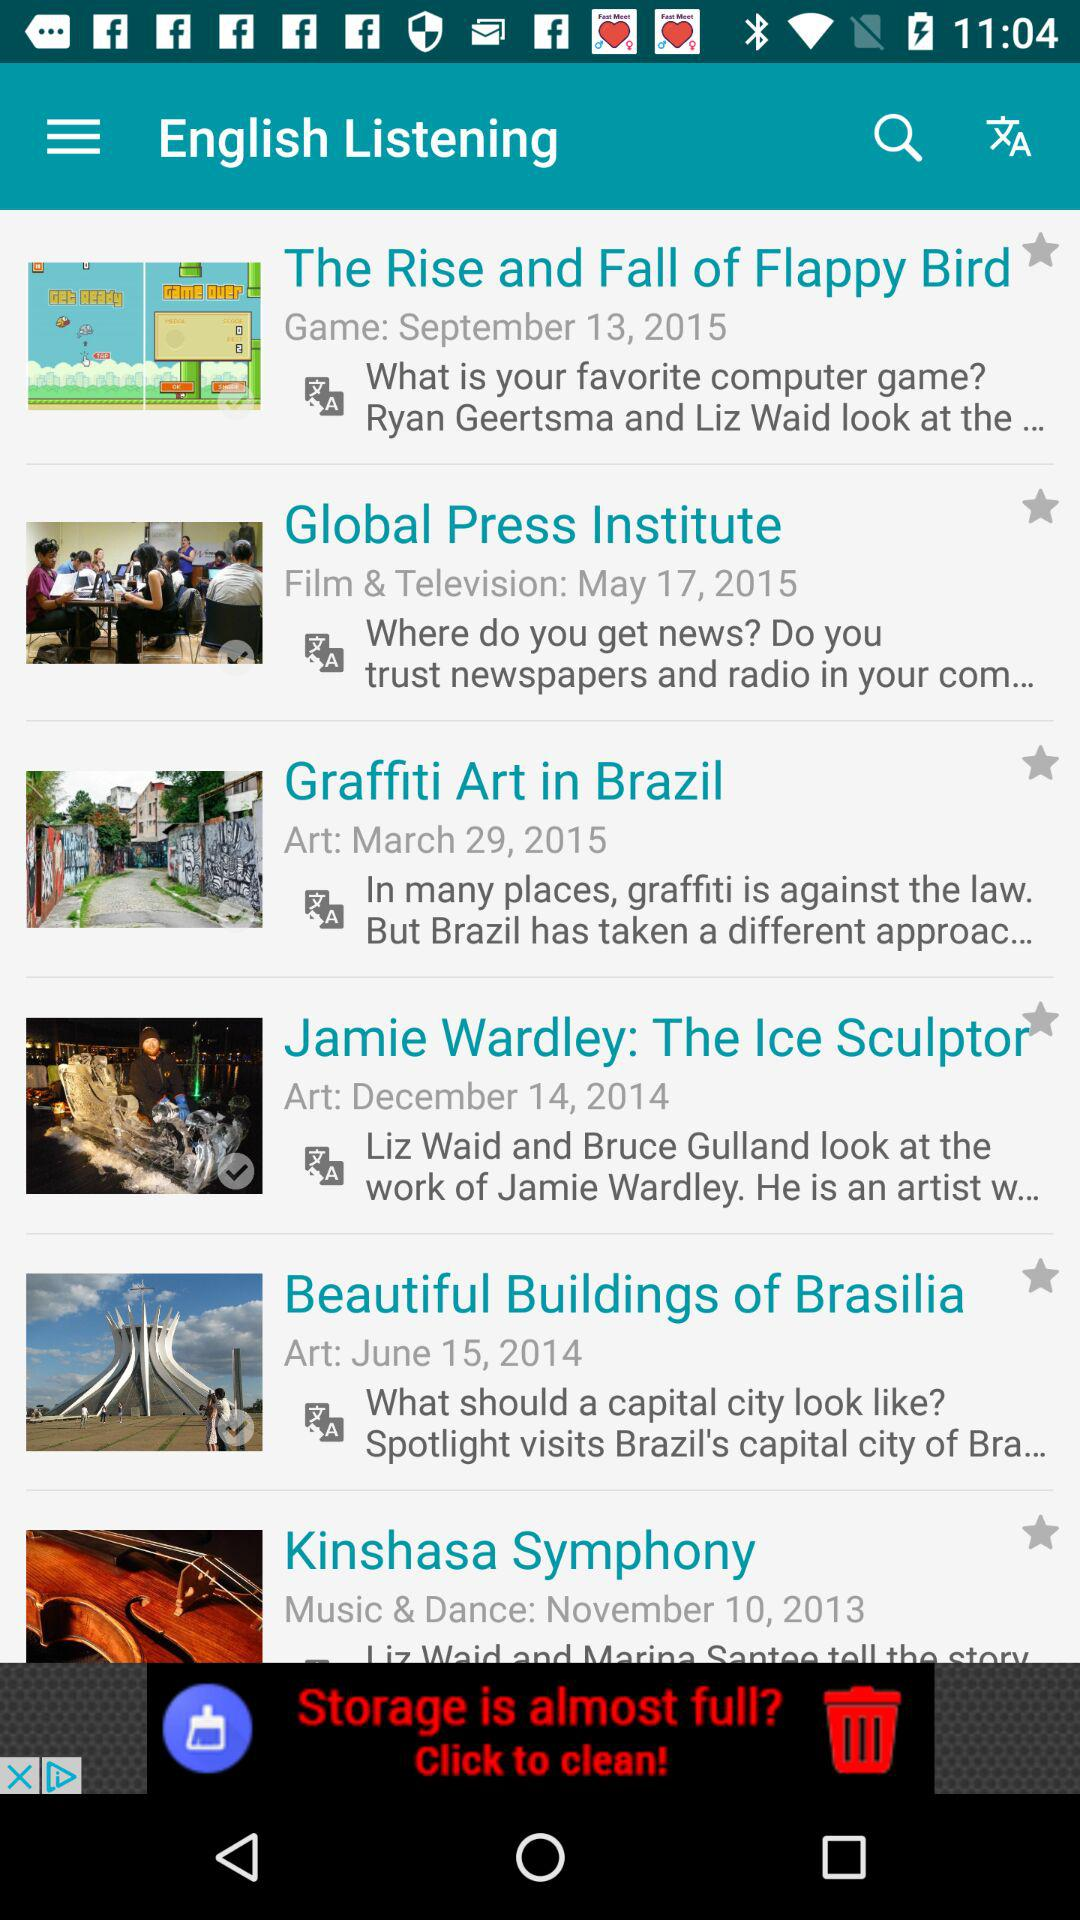What is the date for "Graffiti Art in Brazil"? The date for "Graffiti Art in Brazil" is March 29, 2015. 